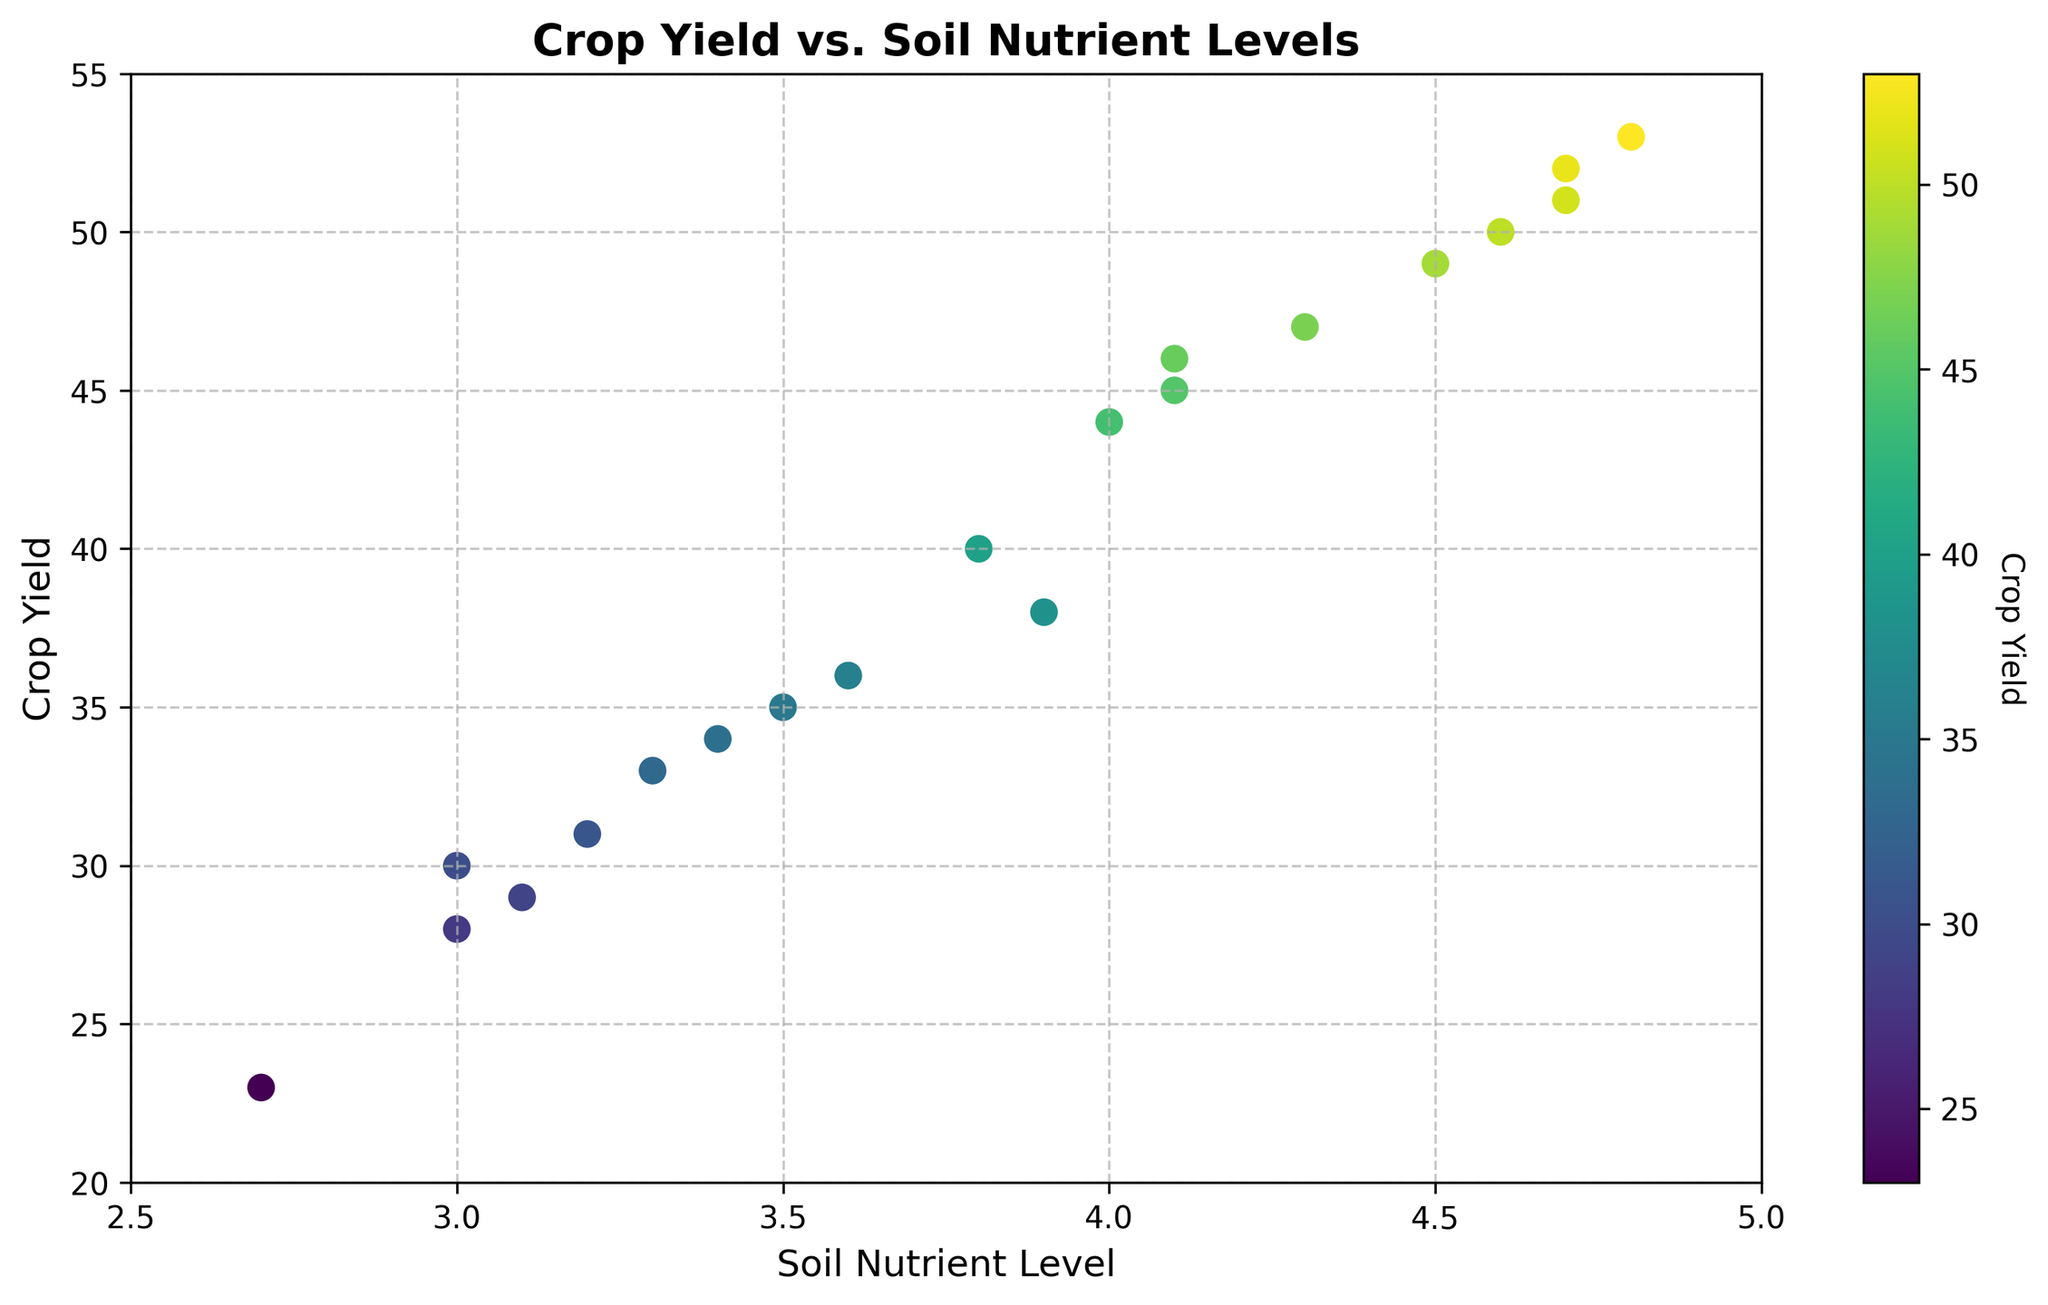What is the general trend observed between Soil Nutrient Level and Crop Yield? By observing the scatter plot, as the Soil Nutrient Level increases, the Crop Yield generally increases as well. This indicates a positive correlation between Soil Nutrient Level and Crop Yield.
Answer: Positive correlation Which data point has the highest Crop Yield and what is its corresponding Soil Nutrient Level? The highest Crop Yield value is 53, and its corresponding Soil Nutrient Level is 4.8 as observed from the scatter plot.
Answer: Crop Yield: 53, Soil Nutrient Level: 4.8 Is there any data point where the Crop Yield is below 30, and if so, what is the Soil Nutrient Level for that point? By inspecting the scatter plot, there are data points with Crop Yields of 23, 29, and 28. Their corresponding Soil Nutrient Levels are 2.7, 3.1, and 3.0 respectively.
Answer: Soil Nutrient Levels: 2.7, 3.1, 3.0 What is the average Crop Yield for the Soil Nutrient Levels greater than 4.0? The Crop Yields for Soil Nutrient Levels greater than 4.0 are 45, 47, 49, 52, 53, 50, 51, and 46. Summing these values gives 393. Then dividing by the number of data points, which is 8, we get an average of 49.125.
Answer: 49.125 Which Soil Nutrient Level has the most varied Crop Yields and what might this indicate? By observing the scatter plot, Soil Nutrient Level 4.7 has the Crop Yields 52 and 51, which are very close. In contrast, 4.1 has Crop Yields 45 and 46, and 3.9 has 38 and 36. Soil Nutrient Level 3.0 has more variance with 30 and 28. This might indicate variability in results at lower nutrient levels.
Answer: Soil Nutrient Level 3.0 Are there any outliers in the scatter plot and what are they if present? By inspecting the scatter plot, there isn't any obvious outlier as most points follow the trend and lie within a logical range based on the rest of the data.
Answer: No apparent outliers 